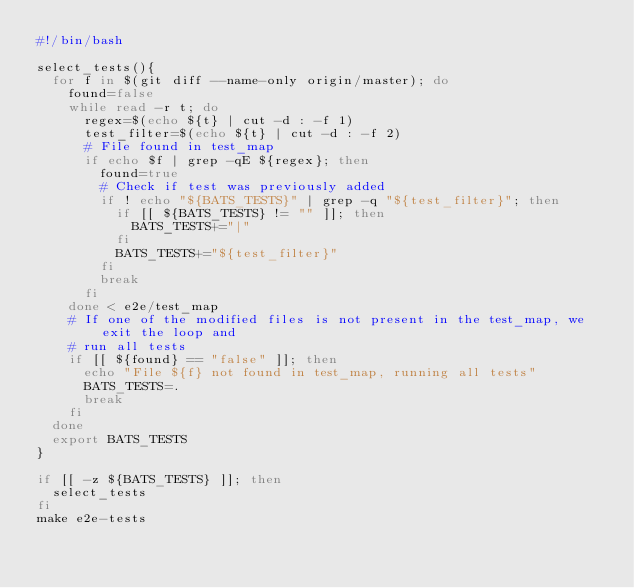<code> <loc_0><loc_0><loc_500><loc_500><_Bash_>#!/bin/bash

select_tests(){
  for f in $(git diff --name-only origin/master); do
    found=false
    while read -r t; do
      regex=$(echo ${t} | cut -d : -f 1)
      test_filter=$(echo ${t} | cut -d : -f 2)
      # File found in test_map
      if echo $f | grep -qE ${regex}; then
        found=true
        # Check if test was previously added
        if ! echo "${BATS_TESTS}" | grep -q "${test_filter}"; then
          if [[ ${BATS_TESTS} != "" ]]; then
            BATS_TESTS+="|"
          fi
          BATS_TESTS+="${test_filter}"
        fi
        break
      fi
    done < e2e/test_map
    # If one of the modified files is not present in the test_map, we exit the loop and
    # run all tests
    if [[ ${found} == "false" ]]; then
      echo "File ${f} not found in test_map, running all tests"
      BATS_TESTS=.
      break
    fi
  done
  export BATS_TESTS
}

if [[ -z ${BATS_TESTS} ]]; then
  select_tests
fi
make e2e-tests
</code> 